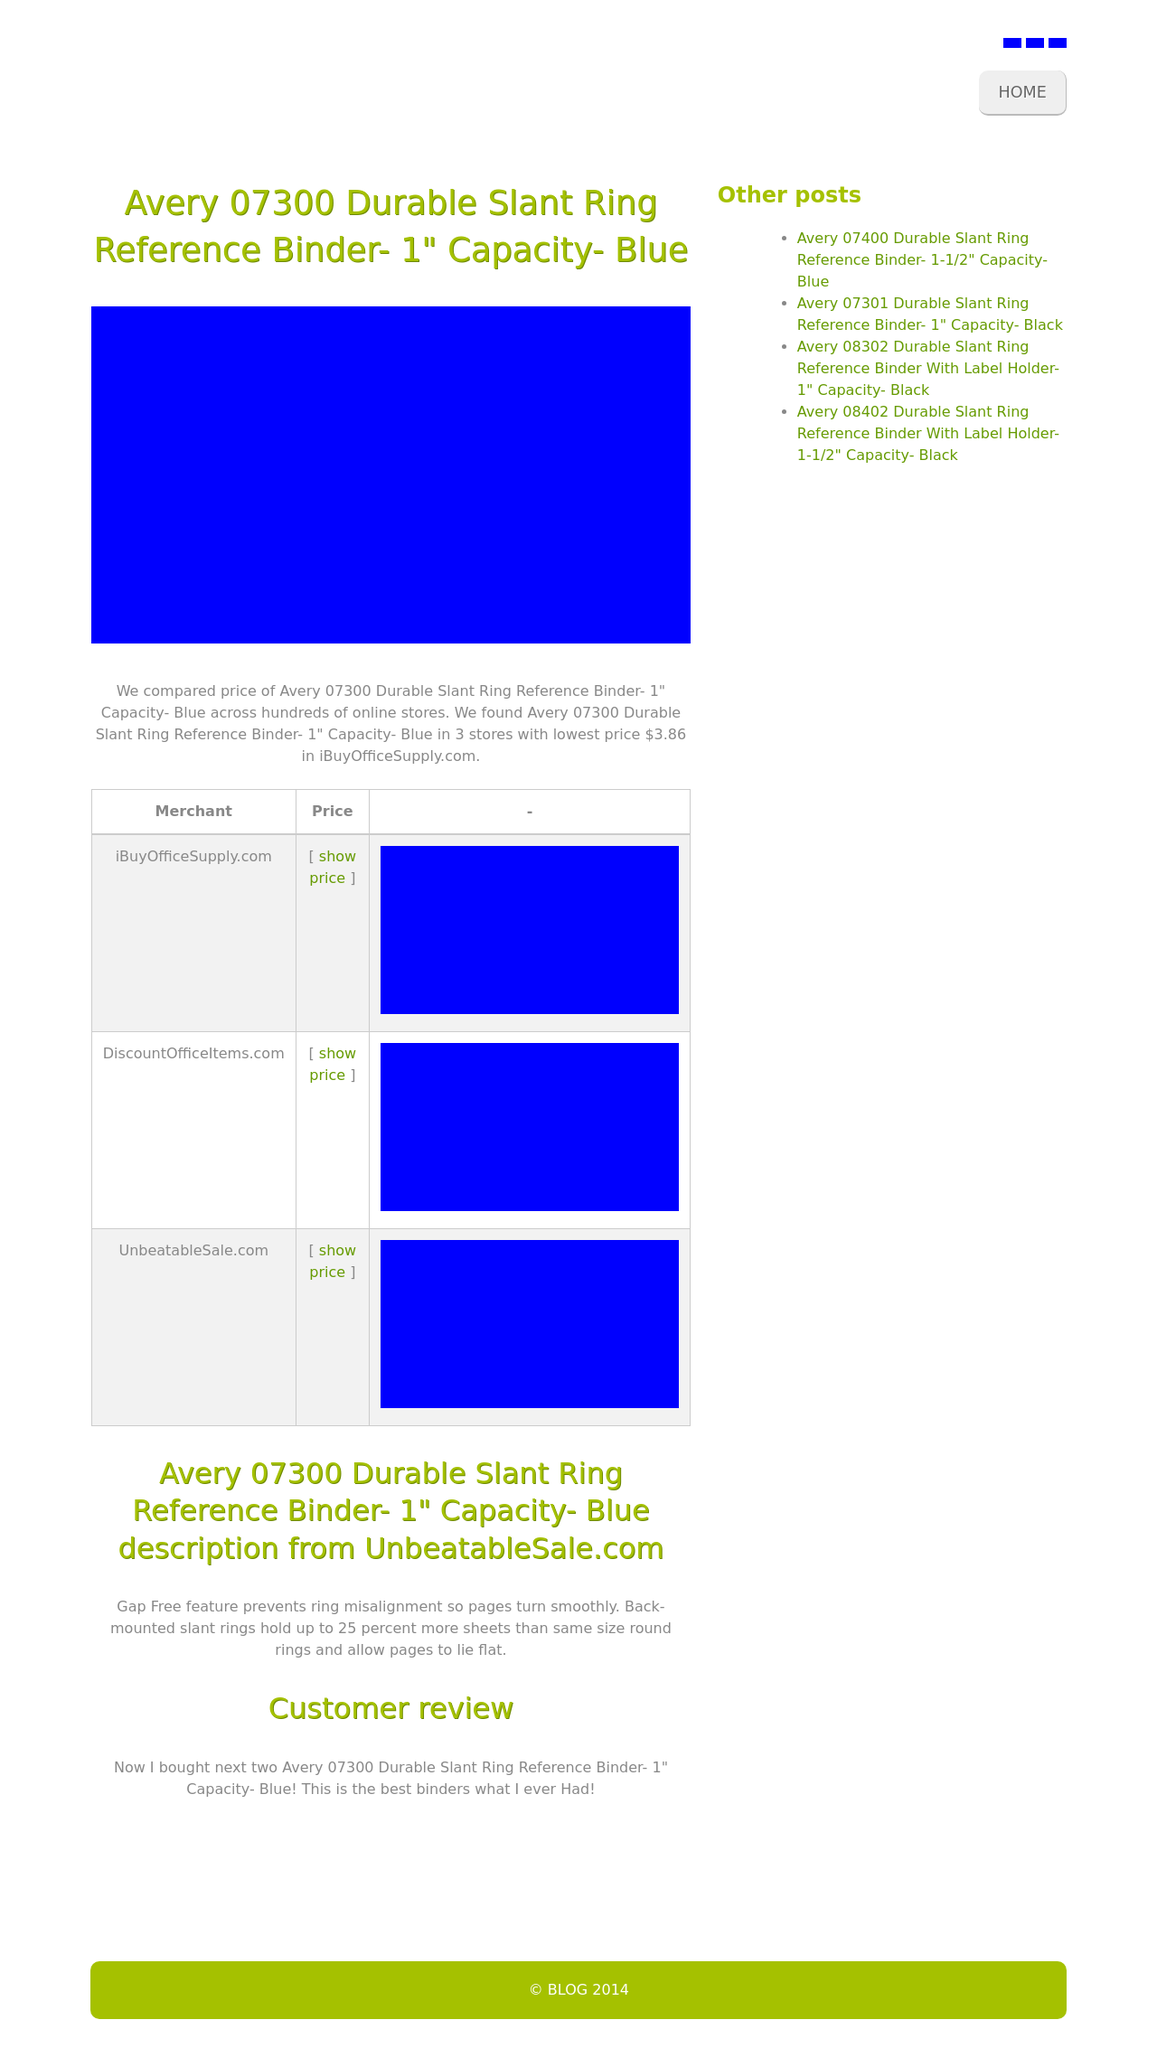How does the layout of this website facilitate user navigation? The layout uses a header with clear navigation links, making it easy for users to find their way around. The main content area is prominently featured in the center with supporting information on the side, which helps to focus the user's attention on the main product while still offering easy access to other relevant content. The footer provides additional information without overwhelming the main interaction space. 